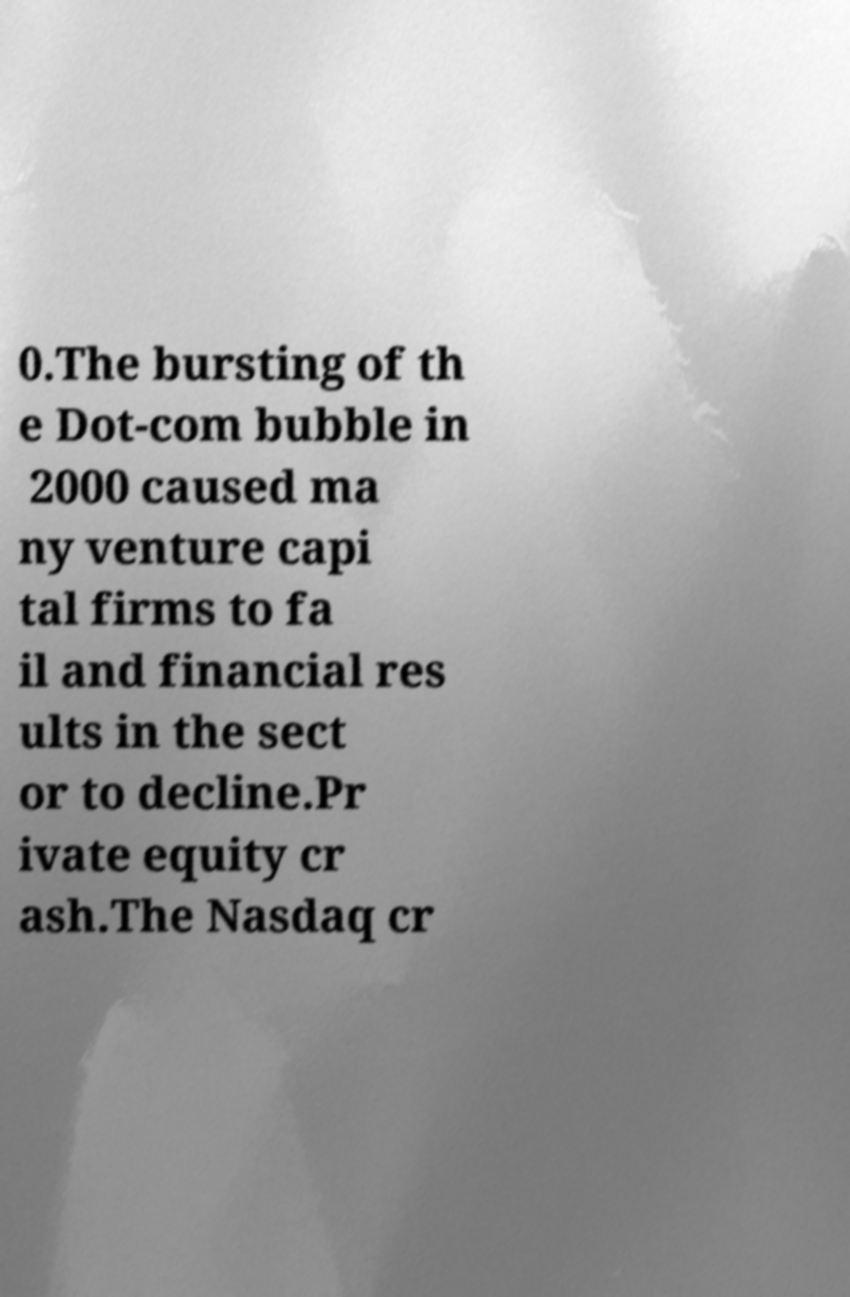Please read and relay the text visible in this image. What does it say? 0.The bursting of th e Dot-com bubble in 2000 caused ma ny venture capi tal firms to fa il and financial res ults in the sect or to decline.Pr ivate equity cr ash.The Nasdaq cr 